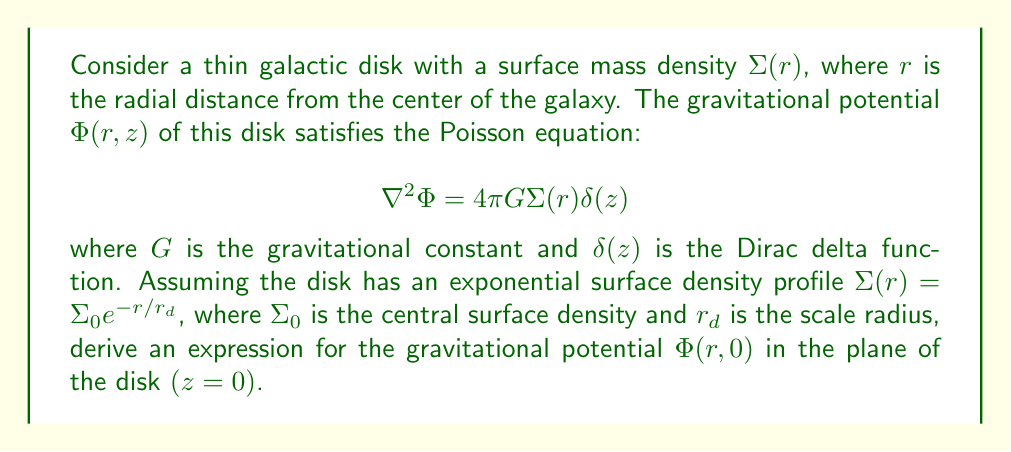What is the answer to this math problem? To solve this problem, we'll follow these steps:

1) First, we need to recognize that due to the axial symmetry of the disk, we can use cylindrical coordinates $(r, \phi, z)$ and the Poisson equation becomes:

   $$\frac{1}{r}\frac{\partial}{\partial r}\left(r\frac{\partial \Phi}{\partial r}\right) + \frac{\partial^2 \Phi}{\partial z^2} = 4\pi G\Sigma_0 e^{-r/r_d}\delta(z)$$

2) We can solve this equation using the method of Green's functions. The Green's function for this problem in cylindrical coordinates is:

   $$G(r,z;r',z') = -\frac{1}{\sqrt{(r-r')^2 + (z-z')^2}}$$

3) The solution for the potential is then given by:

   $$\Phi(r,z) = -G\int_0^\infty \int_0^{2\pi} \frac{\Sigma_0 e^{-r'/r_d} r' dr' d\phi'}{\sqrt{r^2 + r'^2 - 2rr'\cos(\phi') + z^2}}$$

4) In the plane of the disk $(z=0)$, this becomes:

   $$\Phi(r,0) = -2\pi G\Sigma_0 \int_0^\infty \frac{e^{-r'/r_d} r' dr'}{\sqrt{r^2 + r'^2}} K\left(\frac{2\sqrt{rr'}}{r+r'}\right)$$

   where $K(m)$ is the complete elliptic integral of the first kind.

5) This integral doesn't have a closed-form solution, but it can be approximated. For $r \ll r_d$, the potential behaves like:

   $$\Phi(r,0) \approx -2\pi G\Sigma_0 r_d \left[1 - \frac{r}{2r_d} + O\left(\frac{r^2}{r_d^2}\right)\right]$$

6) For $r \gg r_d$, the potential behaves like:

   $$\Phi(r,0) \approx -\frac{GM}{r}\left[1 + O\left(\frac{r_d}{r}\right)\right]$$

   where $M = 2\pi\Sigma_0 r_d^2$ is the total mass of the disk.
Answer: The gravitational potential $\Phi(r,0)$ in the plane of an exponential galactic disk is given by:

$$\Phi(r,0) = -2\pi G\Sigma_0 \int_0^\infty \frac{e^{-r'/r_d} r' dr'}{\sqrt{r^2 + r'^2}} K\left(\frac{2\sqrt{rr'}}{r+r'}\right)$$

This integral doesn't have a closed-form solution, but can be approximated for small and large $r$ as shown in the explanation. 